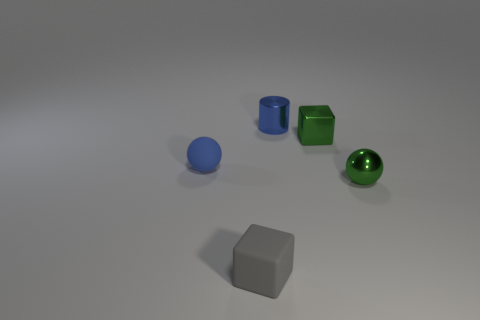Add 2 small green metal things. How many objects exist? 7 Subtract all cylinders. How many objects are left? 4 Add 2 blue matte spheres. How many blue matte spheres are left? 3 Add 5 blue rubber spheres. How many blue rubber spheres exist? 6 Subtract 0 brown balls. How many objects are left? 5 Subtract all purple matte cubes. Subtract all small shiny objects. How many objects are left? 2 